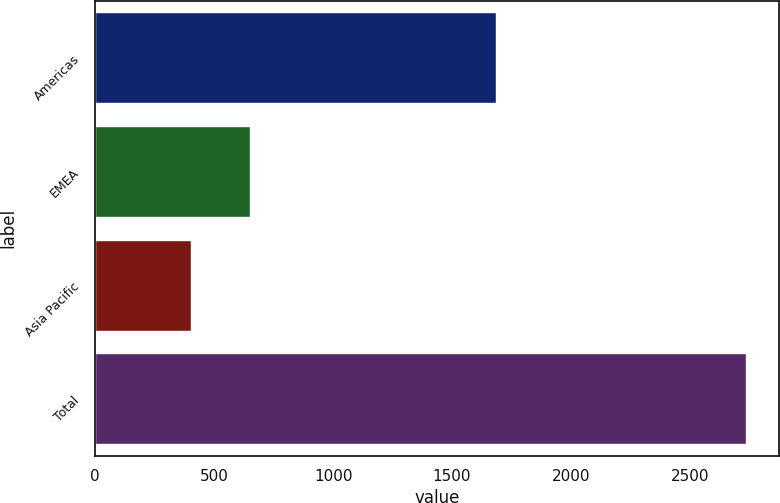Convert chart. <chart><loc_0><loc_0><loc_500><loc_500><bar_chart><fcel>Americas<fcel>EMEA<fcel>Asia Pacific<fcel>Total<nl><fcel>1684.6<fcel>649.5<fcel>401.8<fcel>2735.9<nl></chart> 